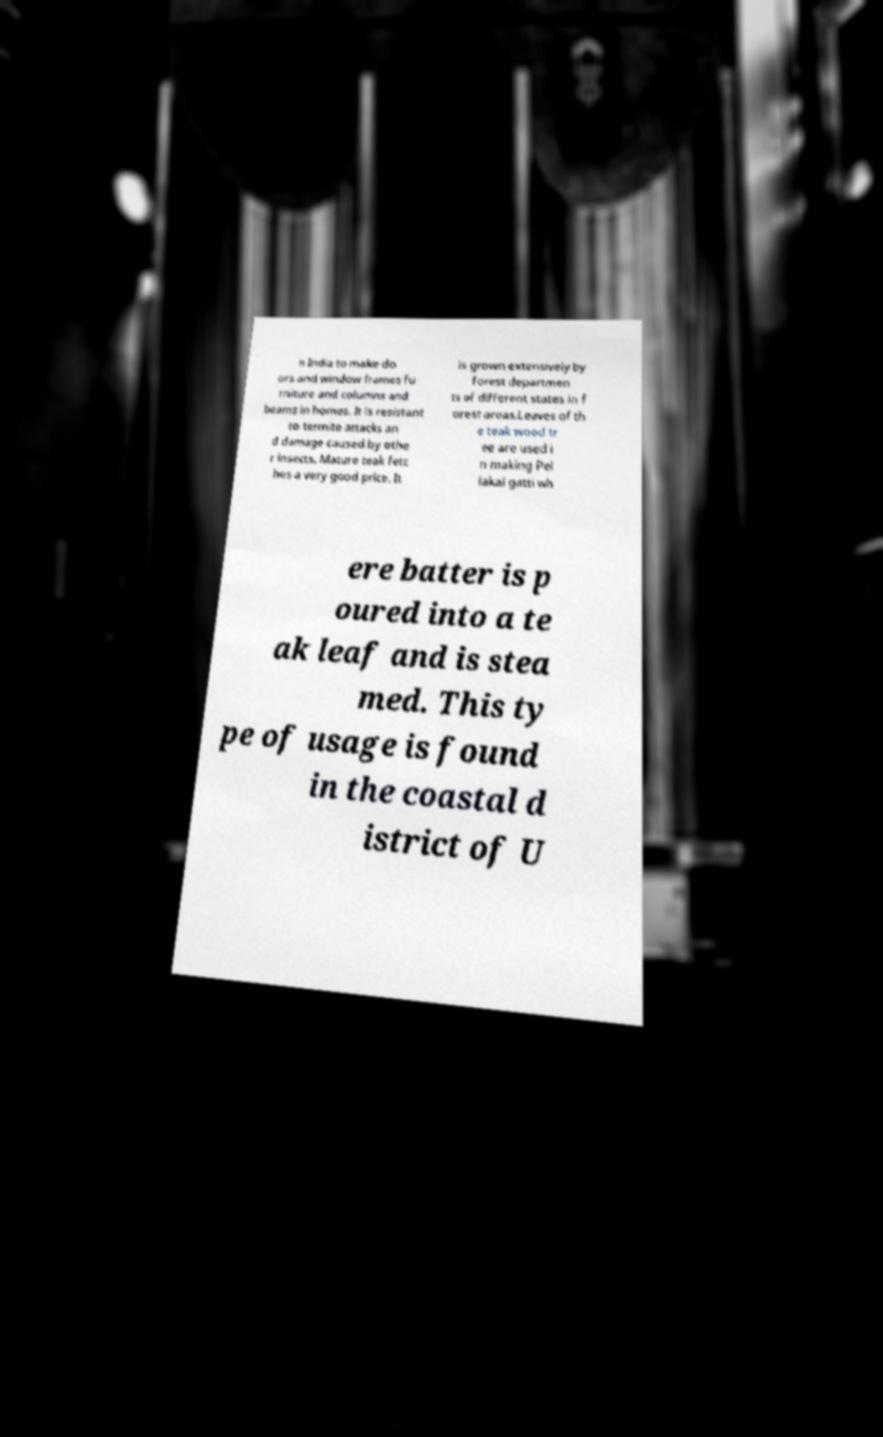There's text embedded in this image that I need extracted. Can you transcribe it verbatim? n India to make do ors and window frames fu rniture and columns and beams in homes. It is resistant to termite attacks an d damage caused by othe r insects. Mature teak fetc hes a very good price. It is grown extensively by forest departmen ts of different states in f orest areas.Leaves of th e teak wood tr ee are used i n making Pel lakai gatti wh ere batter is p oured into a te ak leaf and is stea med. This ty pe of usage is found in the coastal d istrict of U 